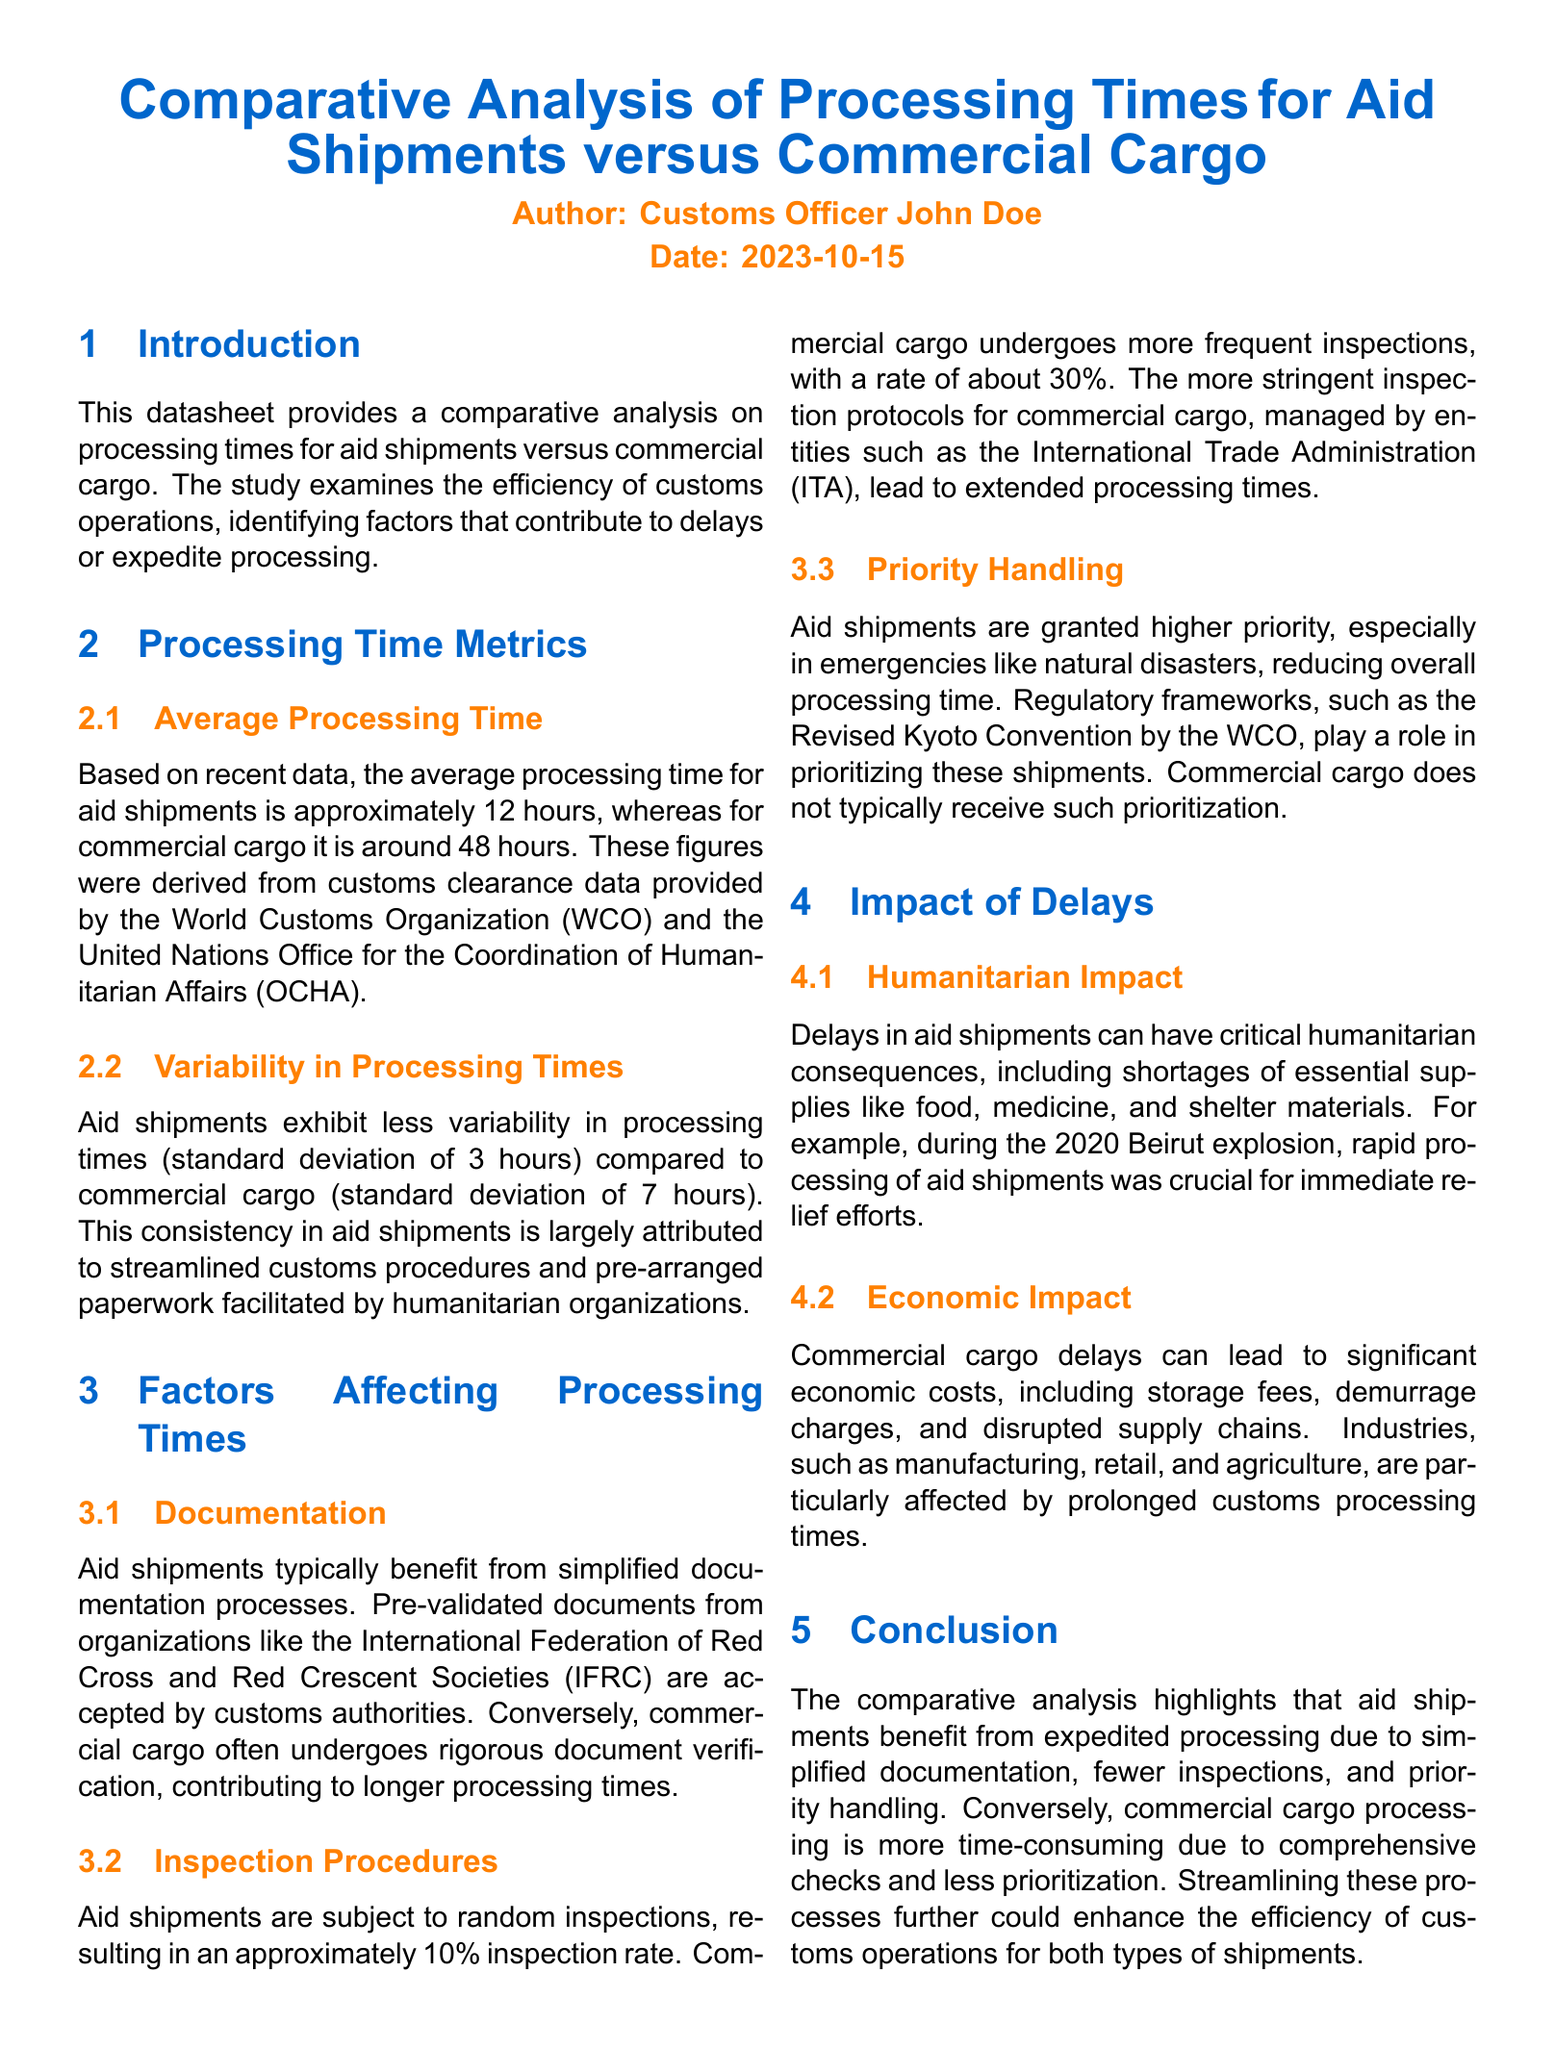what is the average processing time for aid shipments? The average processing time for aid shipments is stated in the document as approximately 12 hours.
Answer: 12 hours what is the average processing time for commercial cargo? The document specifies that the average processing time for commercial cargo is around 48 hours.
Answer: 48 hours what is the standard deviation of processing times for aid shipments? The standard deviation for aid shipments processing times is provided as 3 hours in the document.
Answer: 3 hours what is the inspection rate for aid shipments? The inspection rate for aid shipments is mentioned as approximately 10 percent in the document.
Answer: 10 percent how does the variability in processing times for aid shipments compare to commercial cargo? The document indicates that aid shipments exhibit less variability, with a standard deviation of 3 hours compared to 7 hours for commercial cargo.
Answer: Less variability what regulatory framework prioritizes aid shipments? The Revised Kyoto Convention by the WCO is mentioned in the document as a framework that prioritizes aid shipments.
Answer: Revised Kyoto Convention what humanitarian consequence can result from delays in aid shipments? The document highlights that delays can lead to shortages of essential supplies like food and medicine.
Answer: Shortages what percentage of commercial cargo undergoes inspections? The document states that about 30 percent of commercial cargo is subject to inspections.
Answer: 30 percent what is the date of publication for the document? The publication date is identified as October 15, 2023, in the document.
Answer: 2023-10-15 